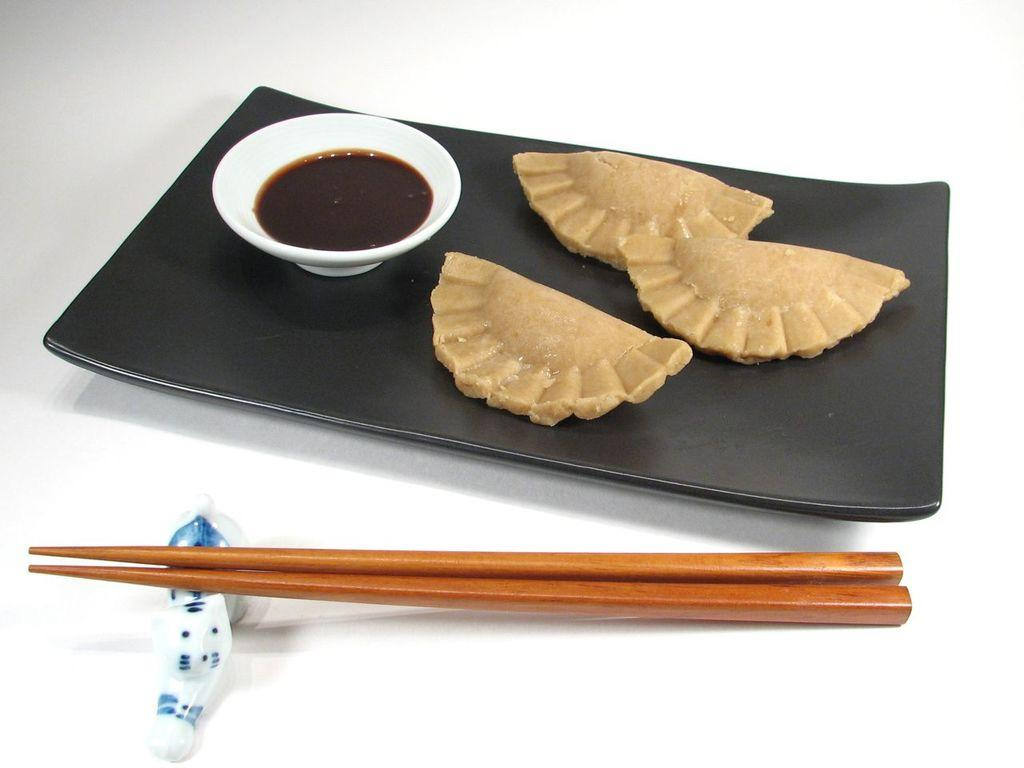What is on the tray that is visible in the image? The tray contains momos in the image. What is in the bowl that is visible in the image? The bowl contains soup in the image. What utensils are present on the table in the image? Chopsticks are present on the table in the image. Can you see any goldfish swimming in the soup in the image? There are no goldfish present in the image; the bowl contains soup without any fish. 